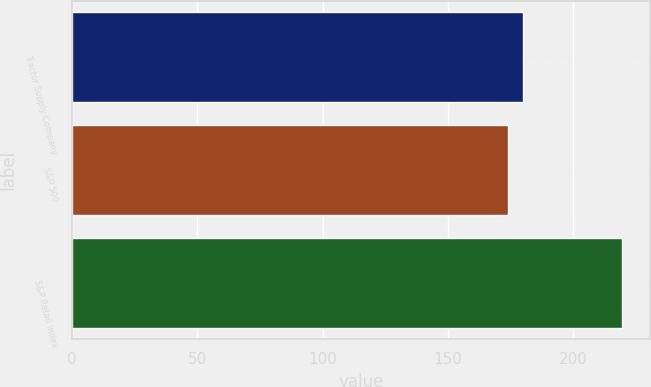Convert chart. <chart><loc_0><loc_0><loc_500><loc_500><bar_chart><fcel>Tractor Supply Company<fcel>S&P 500<fcel>S&P Retail Index<nl><fcel>179.94<fcel>173.74<fcel>219.43<nl></chart> 